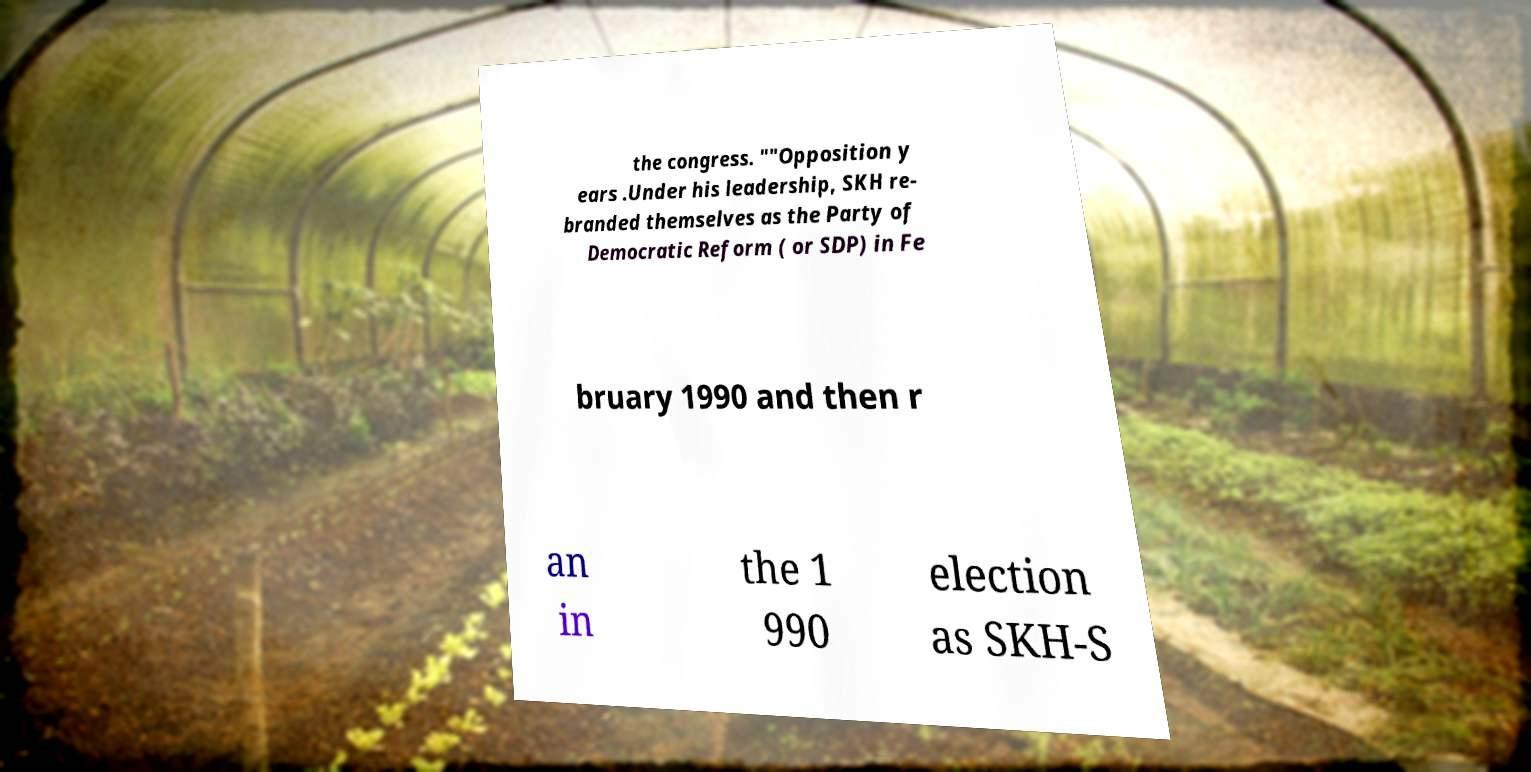Can you accurately transcribe the text from the provided image for me? the congress. ""Opposition y ears .Under his leadership, SKH re- branded themselves as the Party of Democratic Reform ( or SDP) in Fe bruary 1990 and then r an in the 1 990 election as SKH-S 